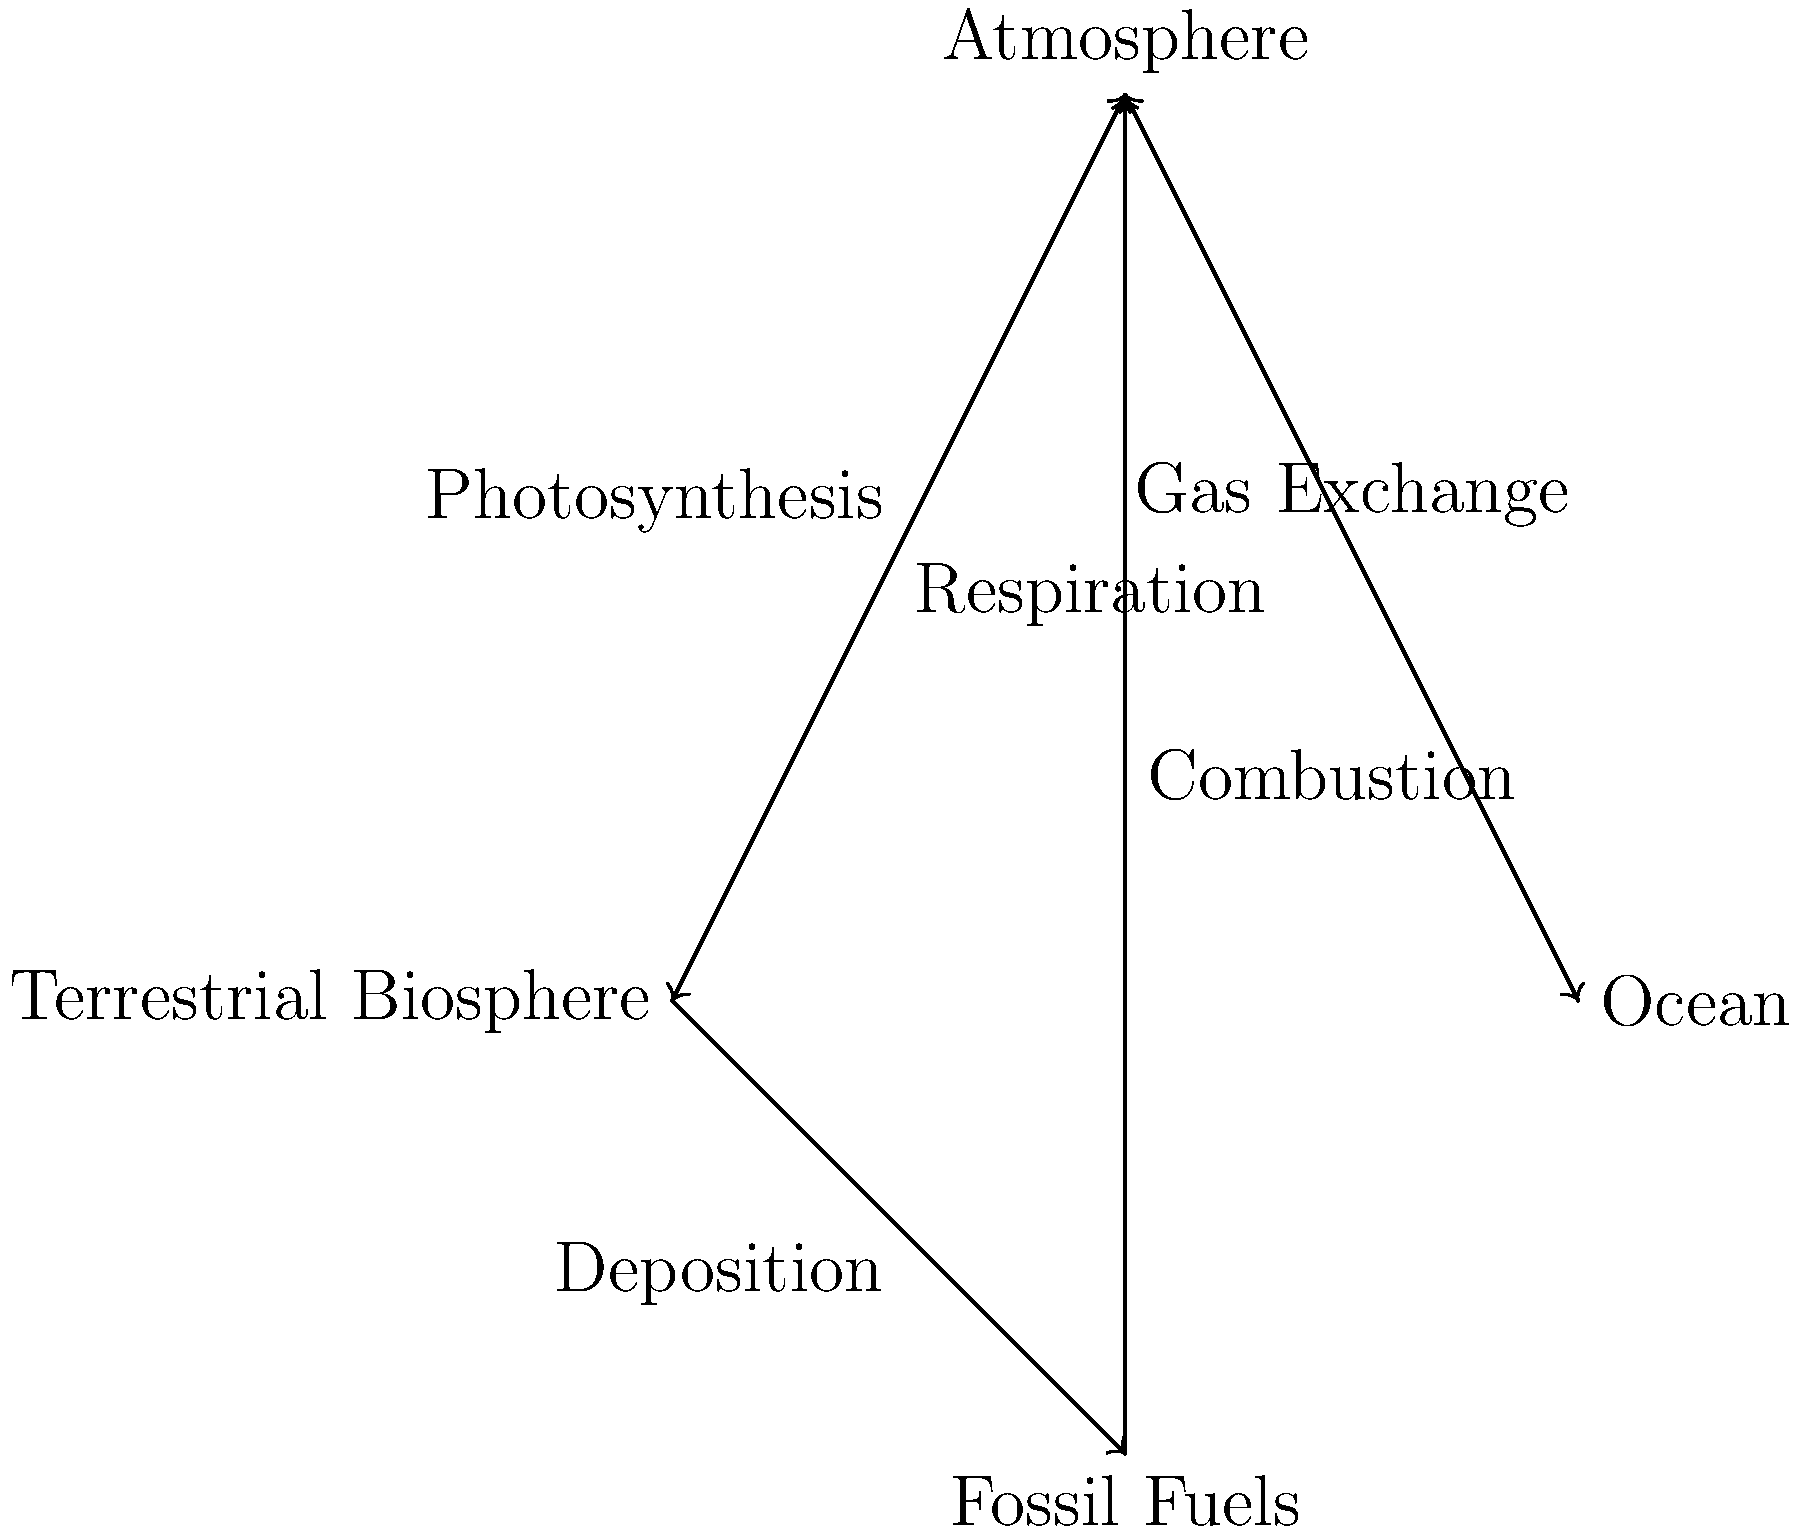In the carbon cycle diagram, which process represents the primary mechanism by which carbon is transferred from the atmosphere to the terrestrial biosphere, and how does this process relate to your microbiology background? To answer this question, let's break it down step-by-step:

1. Examine the diagram: The diagram shows the major components and processes of the carbon cycle, including the atmosphere, terrestrial biosphere, ocean, and fossil fuels.

2. Identify the process: The arrow pointing from the atmosphere to the terrestrial biosphere is labeled "Photosynthesis."

3. Understand photosynthesis: Photosynthesis is the process by which plants, algae, and some bacteria convert light energy, carbon dioxide (CO₂), and water into glucose and oxygen. The general equation for photosynthesis is:

   $$6CO_2 + 6H_2O + \text{light energy} \rightarrow C_6H_{12}O_6 + 6O_2$$

4. Relation to microbiology: As a microbiology major, you would have studied photosynthetic microorganisms such as cyanobacteria and algae. These organisms play a crucial role in the carbon cycle by performing photosynthesis in aquatic environments.

5. Importance in the carbon cycle: Photosynthesis is the primary mechanism for transferring carbon from the atmosphere to the terrestrial biosphere because it:
   a) Removes CO₂ from the atmosphere
   b) Converts inorganic carbon (CO₂) into organic carbon (glucose)
   c) Forms the basis of most food chains and ecosystems

6. Microbial context: In your microbiology studies, you likely explored topics such as:
   a) The evolution of photosynthetic bacteria
   b) The role of microorganisms in global biogeochemical cycles
   c) The molecular mechanisms of photosynthesis in prokaryotes vs. eukaryotes

By understanding photosynthesis and its role in the carbon cycle, microbiologists can better comprehend the global impact of microorganisms on climate, ecosystem function, and carbon sequestration.
Answer: Photosynthesis 